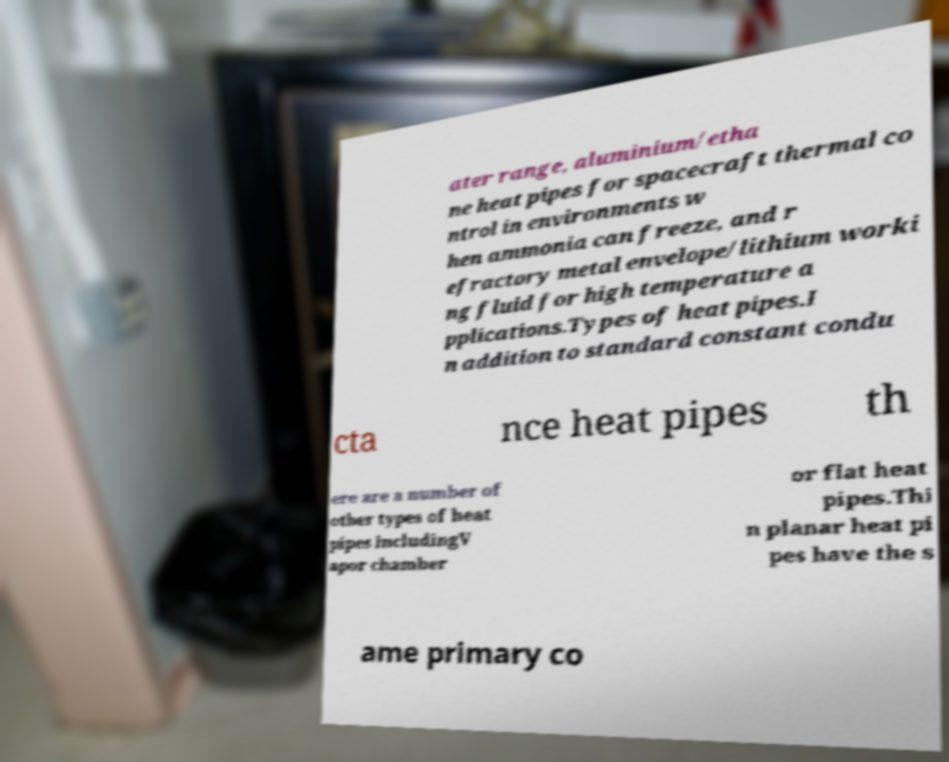There's text embedded in this image that I need extracted. Can you transcribe it verbatim? ater range, aluminium/etha ne heat pipes for spacecraft thermal co ntrol in environments w hen ammonia can freeze, and r efractory metal envelope/lithium worki ng fluid for high temperature a pplications.Types of heat pipes.I n addition to standard constant condu cta nce heat pipes th ere are a number of other types of heat pipes includingV apor chamber or flat heat pipes.Thi n planar heat pi pes have the s ame primary co 